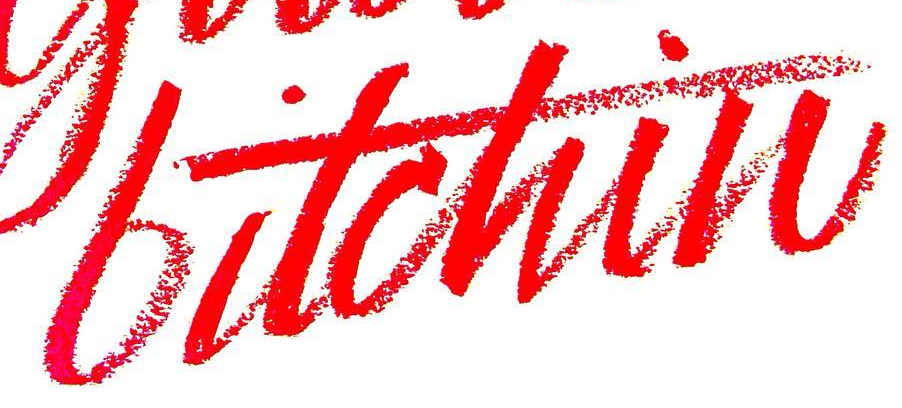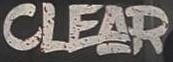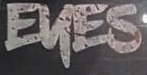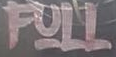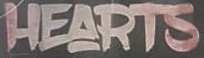What text is displayed in these images sequentially, separated by a semicolon? bitchin; CLEAR; EKES; FULL; HEARTS 